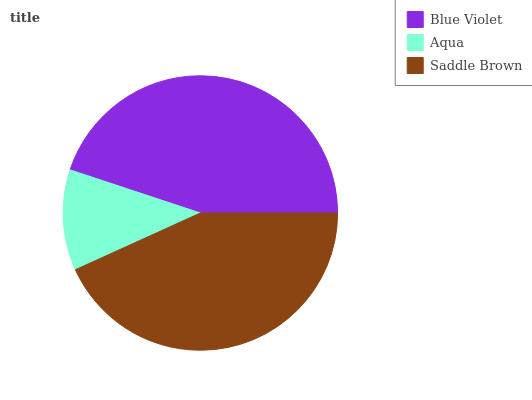Is Aqua the minimum?
Answer yes or no. Yes. Is Blue Violet the maximum?
Answer yes or no. Yes. Is Saddle Brown the minimum?
Answer yes or no. No. Is Saddle Brown the maximum?
Answer yes or no. No. Is Saddle Brown greater than Aqua?
Answer yes or no. Yes. Is Aqua less than Saddle Brown?
Answer yes or no. Yes. Is Aqua greater than Saddle Brown?
Answer yes or no. No. Is Saddle Brown less than Aqua?
Answer yes or no. No. Is Saddle Brown the high median?
Answer yes or no. Yes. Is Saddle Brown the low median?
Answer yes or no. Yes. Is Aqua the high median?
Answer yes or no. No. Is Blue Violet the low median?
Answer yes or no. No. 